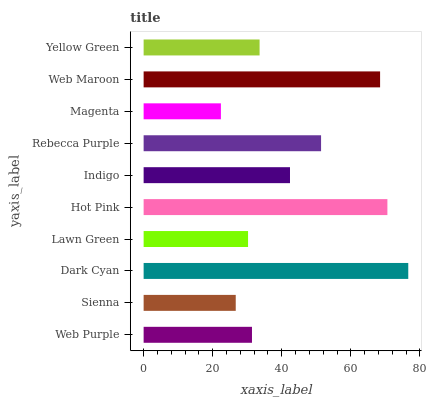Is Magenta the minimum?
Answer yes or no. Yes. Is Dark Cyan the maximum?
Answer yes or no. Yes. Is Sienna the minimum?
Answer yes or no. No. Is Sienna the maximum?
Answer yes or no. No. Is Web Purple greater than Sienna?
Answer yes or no. Yes. Is Sienna less than Web Purple?
Answer yes or no. Yes. Is Sienna greater than Web Purple?
Answer yes or no. No. Is Web Purple less than Sienna?
Answer yes or no. No. Is Indigo the high median?
Answer yes or no. Yes. Is Yellow Green the low median?
Answer yes or no. Yes. Is Yellow Green the high median?
Answer yes or no. No. Is Hot Pink the low median?
Answer yes or no. No. 